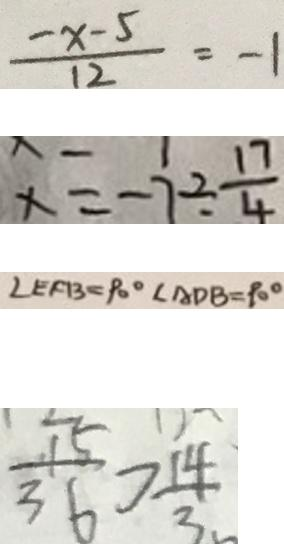<formula> <loc_0><loc_0><loc_500><loc_500>\frac { - x - 5 } { 1 2 } = - 1 
 x = - 7 \div \frac { 1 7 } { 4 } 
 \angle E F B = 9 0 ^ { \circ } \angle A D B = 9 0 ^ { \circ } 
 \frac { 1 5 } { 3 6 } > \frac { 1 4 } { 3 }</formula> 